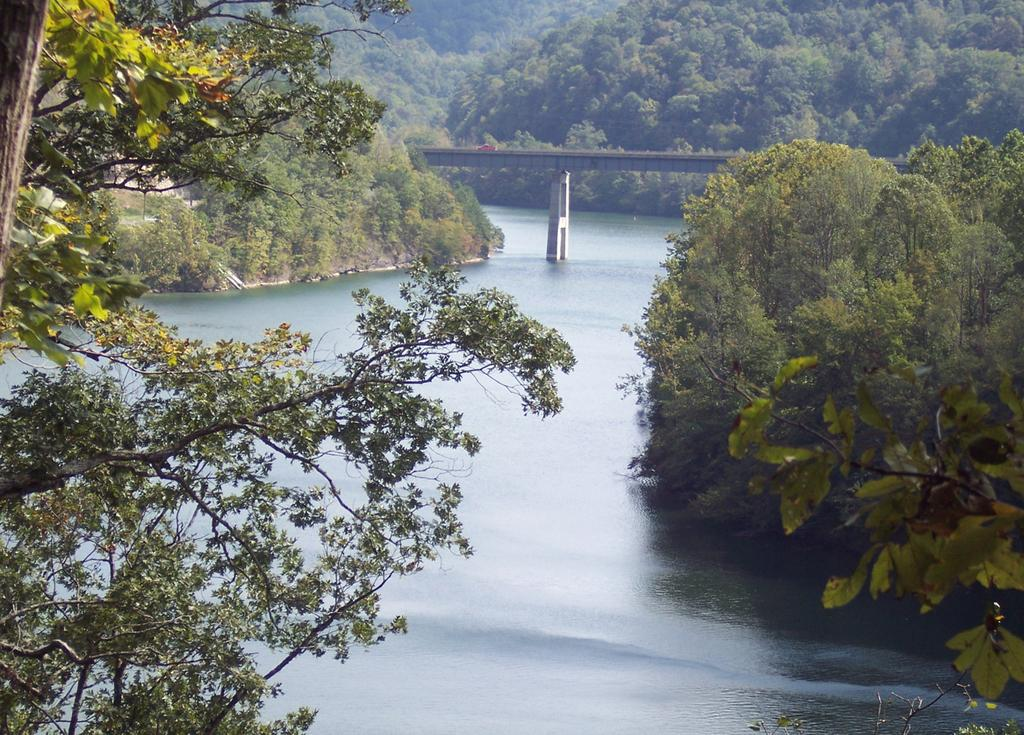What can be seen on either side of the image in the foreground? There are trees in the foreground of the image on either side. What is located in the middle of the image? There is water in the middle of the image. What is visible at the top of the image? There are trees at the top of the image, and a bridge is also visible at the top of the image. How does the water in the image affect the acoustics of the area? The image does not provide information about the acoustics of the area, so it cannot be determined how the water affects it. 